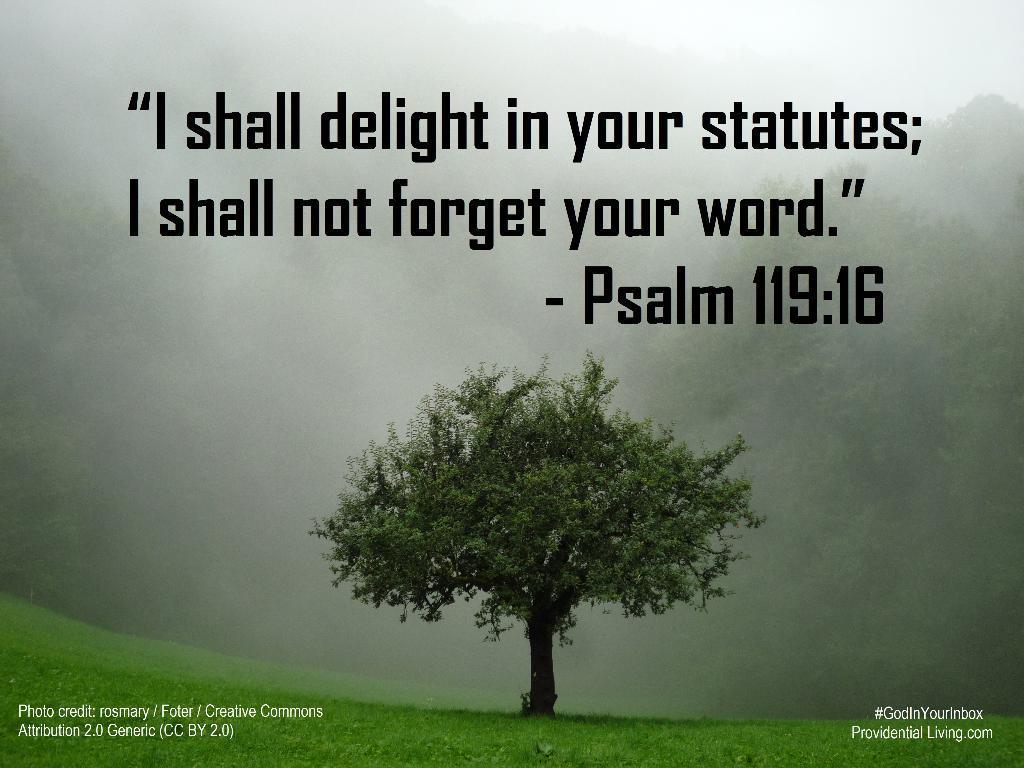Could you give a brief overview of what you see in this image? This image is a poster. At the bottom of the image there is a ground with grass on it. At the top of the image there is a quote. In the middle of the image there is a tree. 